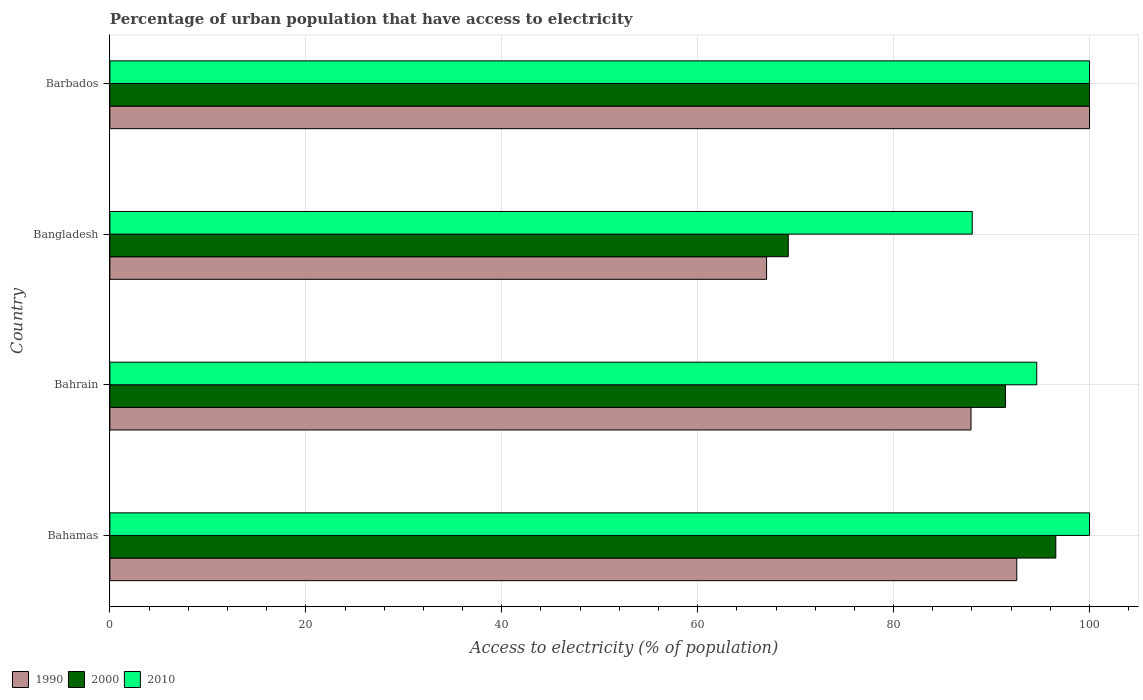How many different coloured bars are there?
Provide a short and direct response. 3. What is the label of the 4th group of bars from the top?
Your response must be concise. Bahamas. What is the percentage of urban population that have access to electricity in 1990 in Bahrain?
Provide a succinct answer. 87.9. Across all countries, what is the maximum percentage of urban population that have access to electricity in 2010?
Your response must be concise. 100. Across all countries, what is the minimum percentage of urban population that have access to electricity in 2010?
Offer a very short reply. 88.03. In which country was the percentage of urban population that have access to electricity in 2010 maximum?
Provide a short and direct response. Bahamas. In which country was the percentage of urban population that have access to electricity in 1990 minimum?
Make the answer very short. Bangladesh. What is the total percentage of urban population that have access to electricity in 2000 in the graph?
Provide a succinct answer. 357.23. What is the difference between the percentage of urban population that have access to electricity in 2010 in Bahamas and that in Bahrain?
Your answer should be very brief. 5.39. What is the difference between the percentage of urban population that have access to electricity in 2000 in Barbados and the percentage of urban population that have access to electricity in 2010 in Bahrain?
Provide a succinct answer. 5.39. What is the average percentage of urban population that have access to electricity in 2000 per country?
Give a very brief answer. 89.31. What is the difference between the percentage of urban population that have access to electricity in 2000 and percentage of urban population that have access to electricity in 2010 in Bangladesh?
Make the answer very short. -18.78. In how many countries, is the percentage of urban population that have access to electricity in 1990 greater than 52 %?
Your answer should be very brief. 4. What is the ratio of the percentage of urban population that have access to electricity in 2010 in Bahamas to that in Bahrain?
Make the answer very short. 1.06. Is the difference between the percentage of urban population that have access to electricity in 2000 in Bahamas and Barbados greater than the difference between the percentage of urban population that have access to electricity in 2010 in Bahamas and Barbados?
Offer a very short reply. No. What is the difference between the highest and the lowest percentage of urban population that have access to electricity in 2000?
Offer a terse response. 30.75. Is it the case that in every country, the sum of the percentage of urban population that have access to electricity in 2000 and percentage of urban population that have access to electricity in 1990 is greater than the percentage of urban population that have access to electricity in 2010?
Your answer should be compact. Yes. How many bars are there?
Keep it short and to the point. 12. What is the difference between two consecutive major ticks on the X-axis?
Your answer should be compact. 20. Does the graph contain any zero values?
Ensure brevity in your answer.  No. How many legend labels are there?
Give a very brief answer. 3. How are the legend labels stacked?
Ensure brevity in your answer.  Horizontal. What is the title of the graph?
Offer a terse response. Percentage of urban population that have access to electricity. What is the label or title of the X-axis?
Give a very brief answer. Access to electricity (% of population). What is the label or title of the Y-axis?
Provide a succinct answer. Country. What is the Access to electricity (% of population) of 1990 in Bahamas?
Keep it short and to the point. 92.57. What is the Access to electricity (% of population) in 2000 in Bahamas?
Your response must be concise. 96.56. What is the Access to electricity (% of population) in 1990 in Bahrain?
Provide a short and direct response. 87.9. What is the Access to electricity (% of population) in 2000 in Bahrain?
Your response must be concise. 91.42. What is the Access to electricity (% of population) in 2010 in Bahrain?
Keep it short and to the point. 94.61. What is the Access to electricity (% of population) in 1990 in Bangladesh?
Keep it short and to the point. 67.04. What is the Access to electricity (% of population) of 2000 in Bangladesh?
Your answer should be very brief. 69.25. What is the Access to electricity (% of population) of 2010 in Bangladesh?
Keep it short and to the point. 88.03. What is the Access to electricity (% of population) of 1990 in Barbados?
Keep it short and to the point. 100. What is the Access to electricity (% of population) in 2010 in Barbados?
Offer a terse response. 100. Across all countries, what is the maximum Access to electricity (% of population) in 2010?
Make the answer very short. 100. Across all countries, what is the minimum Access to electricity (% of population) of 1990?
Keep it short and to the point. 67.04. Across all countries, what is the minimum Access to electricity (% of population) in 2000?
Provide a short and direct response. 69.25. Across all countries, what is the minimum Access to electricity (% of population) of 2010?
Make the answer very short. 88.03. What is the total Access to electricity (% of population) of 1990 in the graph?
Your answer should be very brief. 347.51. What is the total Access to electricity (% of population) of 2000 in the graph?
Offer a terse response. 357.23. What is the total Access to electricity (% of population) of 2010 in the graph?
Your answer should be compact. 382.64. What is the difference between the Access to electricity (% of population) of 1990 in Bahamas and that in Bahrain?
Provide a succinct answer. 4.67. What is the difference between the Access to electricity (% of population) of 2000 in Bahamas and that in Bahrain?
Offer a terse response. 5.14. What is the difference between the Access to electricity (% of population) in 2010 in Bahamas and that in Bahrain?
Give a very brief answer. 5.39. What is the difference between the Access to electricity (% of population) of 1990 in Bahamas and that in Bangladesh?
Give a very brief answer. 25.54. What is the difference between the Access to electricity (% of population) of 2000 in Bahamas and that in Bangladesh?
Keep it short and to the point. 27.31. What is the difference between the Access to electricity (% of population) of 2010 in Bahamas and that in Bangladesh?
Keep it short and to the point. 11.97. What is the difference between the Access to electricity (% of population) in 1990 in Bahamas and that in Barbados?
Your answer should be very brief. -7.43. What is the difference between the Access to electricity (% of population) in 2000 in Bahamas and that in Barbados?
Your answer should be very brief. -3.44. What is the difference between the Access to electricity (% of population) in 2010 in Bahamas and that in Barbados?
Ensure brevity in your answer.  0. What is the difference between the Access to electricity (% of population) of 1990 in Bahrain and that in Bangladesh?
Make the answer very short. 20.87. What is the difference between the Access to electricity (% of population) of 2000 in Bahrain and that in Bangladesh?
Provide a succinct answer. 22.17. What is the difference between the Access to electricity (% of population) in 2010 in Bahrain and that in Bangladesh?
Your response must be concise. 6.58. What is the difference between the Access to electricity (% of population) of 1990 in Bahrain and that in Barbados?
Your answer should be very brief. -12.1. What is the difference between the Access to electricity (% of population) in 2000 in Bahrain and that in Barbados?
Provide a short and direct response. -8.58. What is the difference between the Access to electricity (% of population) in 2010 in Bahrain and that in Barbados?
Provide a short and direct response. -5.39. What is the difference between the Access to electricity (% of population) in 1990 in Bangladesh and that in Barbados?
Your response must be concise. -32.96. What is the difference between the Access to electricity (% of population) of 2000 in Bangladesh and that in Barbados?
Keep it short and to the point. -30.75. What is the difference between the Access to electricity (% of population) of 2010 in Bangladesh and that in Barbados?
Your answer should be compact. -11.97. What is the difference between the Access to electricity (% of population) of 1990 in Bahamas and the Access to electricity (% of population) of 2000 in Bahrain?
Ensure brevity in your answer.  1.15. What is the difference between the Access to electricity (% of population) in 1990 in Bahamas and the Access to electricity (% of population) in 2010 in Bahrain?
Your response must be concise. -2.04. What is the difference between the Access to electricity (% of population) of 2000 in Bahamas and the Access to electricity (% of population) of 2010 in Bahrain?
Make the answer very short. 1.95. What is the difference between the Access to electricity (% of population) in 1990 in Bahamas and the Access to electricity (% of population) in 2000 in Bangladesh?
Ensure brevity in your answer.  23.32. What is the difference between the Access to electricity (% of population) in 1990 in Bahamas and the Access to electricity (% of population) in 2010 in Bangladesh?
Keep it short and to the point. 4.54. What is the difference between the Access to electricity (% of population) in 2000 in Bahamas and the Access to electricity (% of population) in 2010 in Bangladesh?
Your answer should be compact. 8.53. What is the difference between the Access to electricity (% of population) of 1990 in Bahamas and the Access to electricity (% of population) of 2000 in Barbados?
Your response must be concise. -7.43. What is the difference between the Access to electricity (% of population) in 1990 in Bahamas and the Access to electricity (% of population) in 2010 in Barbados?
Provide a short and direct response. -7.43. What is the difference between the Access to electricity (% of population) of 2000 in Bahamas and the Access to electricity (% of population) of 2010 in Barbados?
Offer a very short reply. -3.44. What is the difference between the Access to electricity (% of population) of 1990 in Bahrain and the Access to electricity (% of population) of 2000 in Bangladesh?
Your answer should be very brief. 18.65. What is the difference between the Access to electricity (% of population) in 1990 in Bahrain and the Access to electricity (% of population) in 2010 in Bangladesh?
Provide a short and direct response. -0.13. What is the difference between the Access to electricity (% of population) of 2000 in Bahrain and the Access to electricity (% of population) of 2010 in Bangladesh?
Ensure brevity in your answer.  3.39. What is the difference between the Access to electricity (% of population) of 1990 in Bahrain and the Access to electricity (% of population) of 2000 in Barbados?
Keep it short and to the point. -12.1. What is the difference between the Access to electricity (% of population) of 1990 in Bahrain and the Access to electricity (% of population) of 2010 in Barbados?
Keep it short and to the point. -12.1. What is the difference between the Access to electricity (% of population) of 2000 in Bahrain and the Access to electricity (% of population) of 2010 in Barbados?
Your answer should be very brief. -8.58. What is the difference between the Access to electricity (% of population) in 1990 in Bangladesh and the Access to electricity (% of population) in 2000 in Barbados?
Your answer should be compact. -32.96. What is the difference between the Access to electricity (% of population) of 1990 in Bangladesh and the Access to electricity (% of population) of 2010 in Barbados?
Provide a succinct answer. -32.96. What is the difference between the Access to electricity (% of population) in 2000 in Bangladesh and the Access to electricity (% of population) in 2010 in Barbados?
Ensure brevity in your answer.  -30.75. What is the average Access to electricity (% of population) in 1990 per country?
Provide a succinct answer. 86.88. What is the average Access to electricity (% of population) of 2000 per country?
Provide a succinct answer. 89.31. What is the average Access to electricity (% of population) of 2010 per country?
Offer a very short reply. 95.66. What is the difference between the Access to electricity (% of population) of 1990 and Access to electricity (% of population) of 2000 in Bahamas?
Offer a terse response. -3.99. What is the difference between the Access to electricity (% of population) of 1990 and Access to electricity (% of population) of 2010 in Bahamas?
Ensure brevity in your answer.  -7.43. What is the difference between the Access to electricity (% of population) of 2000 and Access to electricity (% of population) of 2010 in Bahamas?
Your response must be concise. -3.44. What is the difference between the Access to electricity (% of population) in 1990 and Access to electricity (% of population) in 2000 in Bahrain?
Offer a terse response. -3.52. What is the difference between the Access to electricity (% of population) of 1990 and Access to electricity (% of population) of 2010 in Bahrain?
Keep it short and to the point. -6.71. What is the difference between the Access to electricity (% of population) of 2000 and Access to electricity (% of population) of 2010 in Bahrain?
Provide a short and direct response. -3.19. What is the difference between the Access to electricity (% of population) of 1990 and Access to electricity (% of population) of 2000 in Bangladesh?
Provide a short and direct response. -2.21. What is the difference between the Access to electricity (% of population) of 1990 and Access to electricity (% of population) of 2010 in Bangladesh?
Ensure brevity in your answer.  -20.99. What is the difference between the Access to electricity (% of population) of 2000 and Access to electricity (% of population) of 2010 in Bangladesh?
Your response must be concise. -18.78. What is the ratio of the Access to electricity (% of population) of 1990 in Bahamas to that in Bahrain?
Offer a very short reply. 1.05. What is the ratio of the Access to electricity (% of population) in 2000 in Bahamas to that in Bahrain?
Provide a succinct answer. 1.06. What is the ratio of the Access to electricity (% of population) in 2010 in Bahamas to that in Bahrain?
Your answer should be very brief. 1.06. What is the ratio of the Access to electricity (% of population) of 1990 in Bahamas to that in Bangladesh?
Keep it short and to the point. 1.38. What is the ratio of the Access to electricity (% of population) of 2000 in Bahamas to that in Bangladesh?
Your answer should be very brief. 1.39. What is the ratio of the Access to electricity (% of population) in 2010 in Bahamas to that in Bangladesh?
Make the answer very short. 1.14. What is the ratio of the Access to electricity (% of population) in 1990 in Bahamas to that in Barbados?
Your answer should be compact. 0.93. What is the ratio of the Access to electricity (% of population) in 2000 in Bahamas to that in Barbados?
Provide a succinct answer. 0.97. What is the ratio of the Access to electricity (% of population) of 1990 in Bahrain to that in Bangladesh?
Provide a short and direct response. 1.31. What is the ratio of the Access to electricity (% of population) in 2000 in Bahrain to that in Bangladesh?
Offer a terse response. 1.32. What is the ratio of the Access to electricity (% of population) of 2010 in Bahrain to that in Bangladesh?
Your response must be concise. 1.07. What is the ratio of the Access to electricity (% of population) of 1990 in Bahrain to that in Barbados?
Provide a succinct answer. 0.88. What is the ratio of the Access to electricity (% of population) of 2000 in Bahrain to that in Barbados?
Your answer should be very brief. 0.91. What is the ratio of the Access to electricity (% of population) of 2010 in Bahrain to that in Barbados?
Keep it short and to the point. 0.95. What is the ratio of the Access to electricity (% of population) in 1990 in Bangladesh to that in Barbados?
Your response must be concise. 0.67. What is the ratio of the Access to electricity (% of population) in 2000 in Bangladesh to that in Barbados?
Provide a succinct answer. 0.69. What is the ratio of the Access to electricity (% of population) of 2010 in Bangladesh to that in Barbados?
Give a very brief answer. 0.88. What is the difference between the highest and the second highest Access to electricity (% of population) in 1990?
Provide a succinct answer. 7.43. What is the difference between the highest and the second highest Access to electricity (% of population) of 2000?
Keep it short and to the point. 3.44. What is the difference between the highest and the lowest Access to electricity (% of population) in 1990?
Your answer should be compact. 32.96. What is the difference between the highest and the lowest Access to electricity (% of population) of 2000?
Provide a short and direct response. 30.75. What is the difference between the highest and the lowest Access to electricity (% of population) in 2010?
Your answer should be compact. 11.97. 